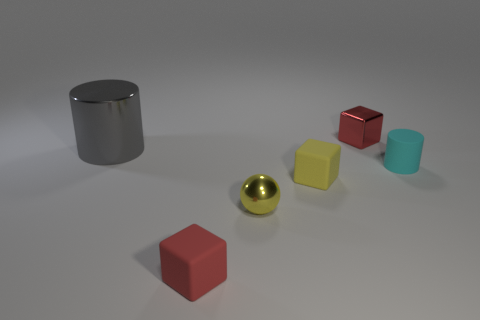There is a tiny object that is the same color as the small shiny cube; what shape is it?
Offer a terse response. Cube. What number of gray shiny objects are to the right of the red metal object?
Provide a succinct answer. 0. Is the shape of the gray object the same as the cyan rubber object?
Provide a short and direct response. Yes. How many tiny things are on the left side of the tiny cyan rubber object and in front of the large gray thing?
Your answer should be compact. 3. How many things are tiny yellow blocks or tiny things right of the red matte block?
Ensure brevity in your answer.  4. Is the number of large metal blocks greater than the number of yellow spheres?
Make the answer very short. No. What shape is the small metallic thing that is to the right of the yellow metal object?
Provide a succinct answer. Cube. What number of tiny cyan matte objects are the same shape as the small red rubber thing?
Provide a short and direct response. 0. What size is the red block that is behind the tiny rubber thing that is in front of the yellow matte thing?
Provide a succinct answer. Small. What number of brown objects are either large things or balls?
Keep it short and to the point. 0. 